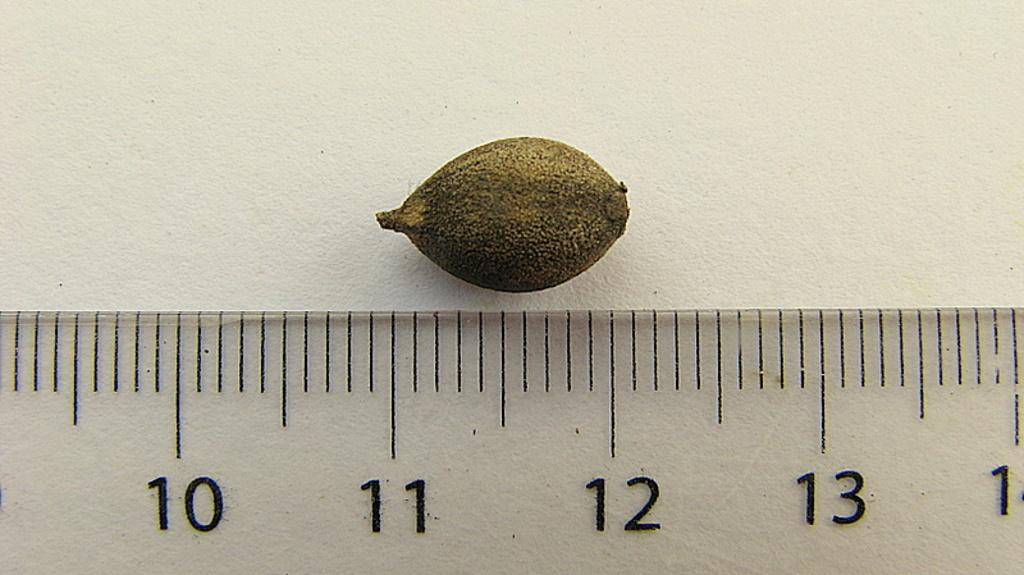<image>
Write a terse but informative summary of the picture. A ruler with the numbers 10-13 on it under a nut. 